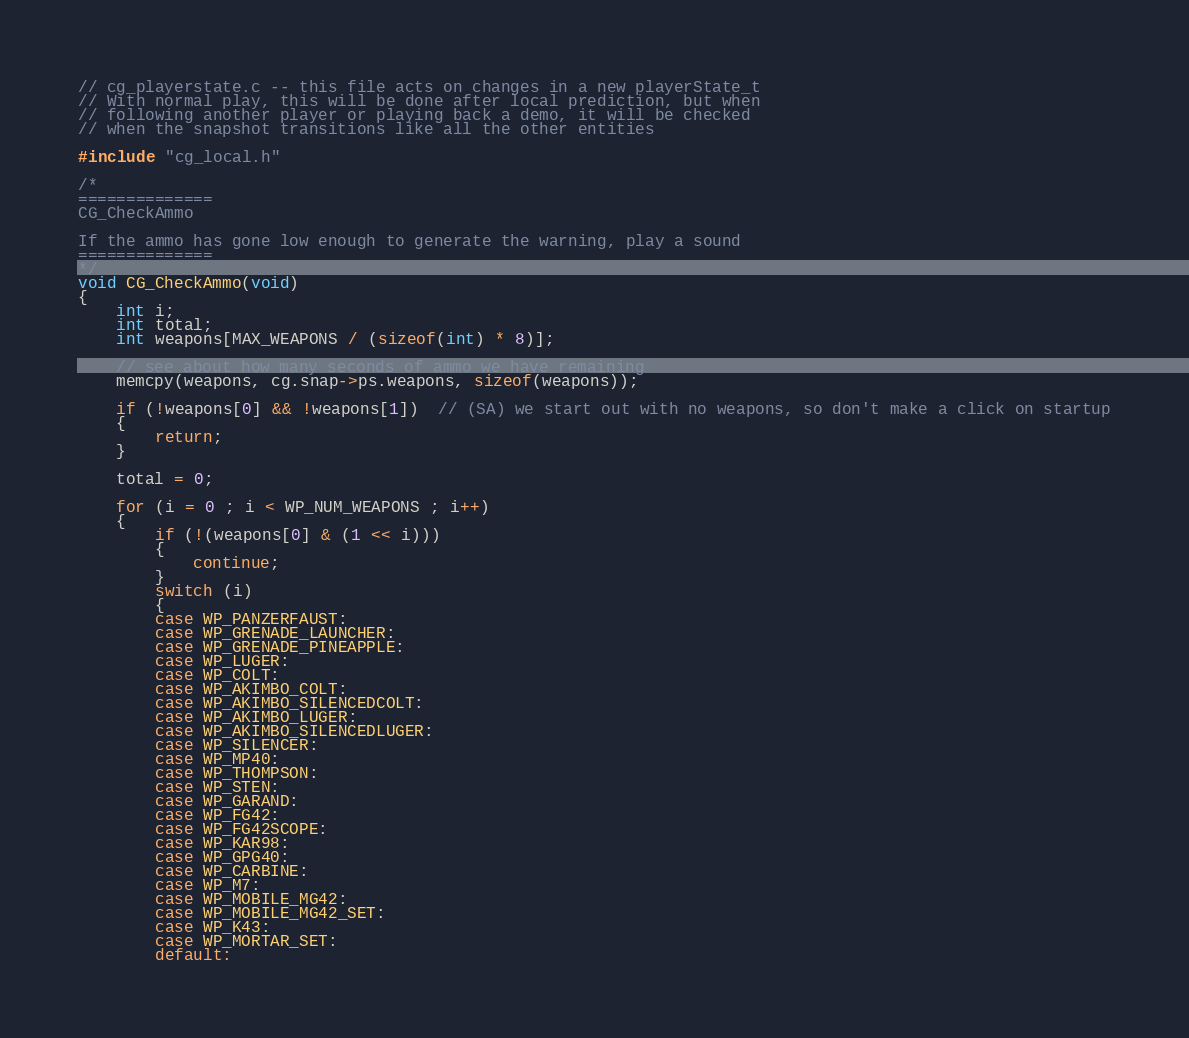Convert code to text. <code><loc_0><loc_0><loc_500><loc_500><_C++_>

// cg_playerstate.c -- this file acts on changes in a new playerState_t
// With normal play, this will be done after local prediction, but when
// following another player or playing back a demo, it will be checked
// when the snapshot transitions like all the other entities

#include "cg_local.h"

/*
==============
CG_CheckAmmo

If the ammo has gone low enough to generate the warning, play a sound
==============
*/
void CG_CheckAmmo(void)
{
	int i;
	int total;
	int weapons[MAX_WEAPONS / (sizeof(int) * 8)];

	// see about how many seconds of ammo we have remaining
	memcpy(weapons, cg.snap->ps.weapons, sizeof(weapons));

	if (!weapons[0] && !weapons[1])  // (SA) we start out with no weapons, so don't make a click on startup
	{
		return;
	}

	total = 0;

	for (i = 0 ; i < WP_NUM_WEAPONS ; i++)
	{
		if (!(weapons[0] & (1 << i)))
		{
			continue;
		}
		switch (i)
		{
		case WP_PANZERFAUST:
		case WP_GRENADE_LAUNCHER:
		case WP_GRENADE_PINEAPPLE:
		case WP_LUGER:
		case WP_COLT:
		case WP_AKIMBO_COLT:
		case WP_AKIMBO_SILENCEDCOLT:
		case WP_AKIMBO_LUGER:
		case WP_AKIMBO_SILENCEDLUGER:
		case WP_SILENCER:
		case WP_MP40:
		case WP_THOMPSON:
		case WP_STEN:
		case WP_GARAND:
		case WP_FG42:
		case WP_FG42SCOPE:
		case WP_KAR98:
		case WP_GPG40:
		case WP_CARBINE:
		case WP_M7:
		case WP_MOBILE_MG42:
		case WP_MOBILE_MG42_SET:
		case WP_K43:
		case WP_MORTAR_SET:
		default:</code> 